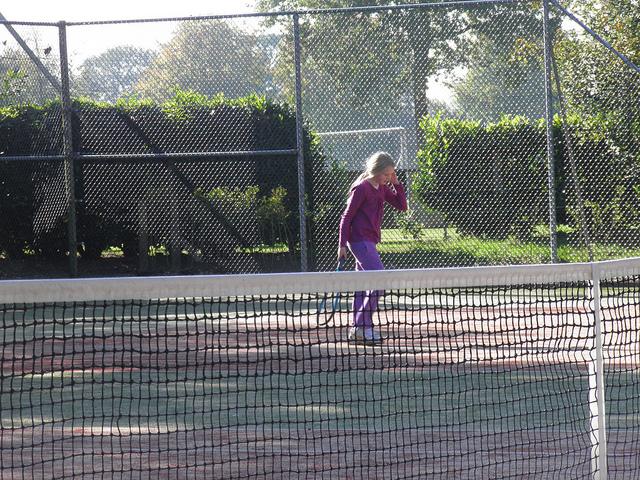What color are her pants?
Write a very short answer. Purple. Is this woman a professional athlete?
Write a very short answer. No. Is the woman playing tennis at the moment?
Keep it brief. Yes. What are the people in the photo playing?
Be succinct. Tennis. What is this sport?
Write a very short answer. Tennis. 